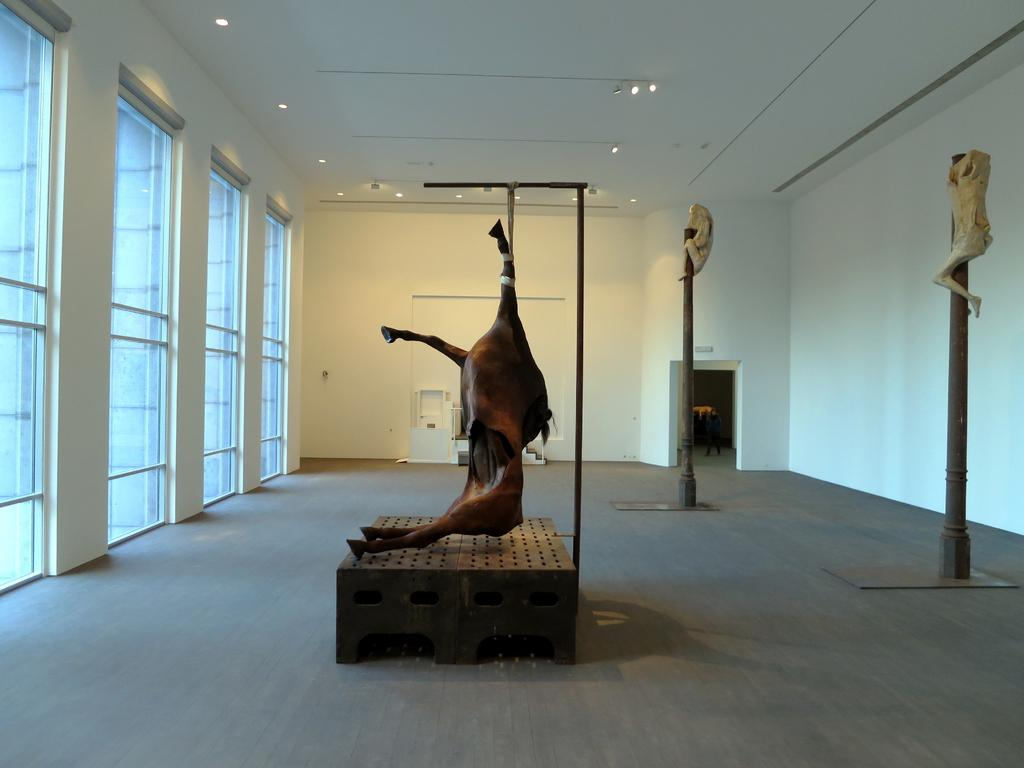What is the color of the wall in the image? The wall in the image is white. What can be seen on the wall in the image? There are statues on the wall in the image. What architectural features are present in the image? There are windows and lights in the image. Can you see a donkey using a brush to bite the wall in the image? No, there is no donkey or brush present in the image, and the wall is not being bitten. 